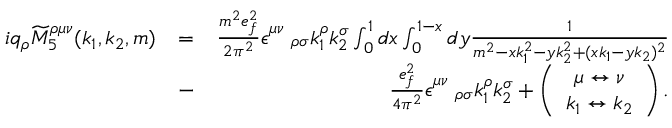<formula> <loc_0><loc_0><loc_500><loc_500>\begin{array} { r l r } { i q _ { \rho } \widetilde { M } _ { 5 } ^ { \rho \mu \nu } ( k _ { 1 } , k _ { 2 } , m ) } & { = } & { \frac { m ^ { 2 } e _ { f } ^ { 2 } } { 2 \pi ^ { 2 } } \epsilon _ { \quad \rho \sigma } ^ { \mu \nu } k _ { 1 } ^ { \rho } k _ { 2 } ^ { \sigma } \int _ { 0 } ^ { 1 } d x \int _ { 0 } ^ { 1 - x } d y \frac { 1 } { m ^ { 2 } - x k _ { 1 } ^ { 2 } - y k _ { 2 } ^ { 2 } + ( x k _ { 1 } - y k _ { 2 } ) ^ { 2 } } } \\ & { - } & { \frac { e _ { f } ^ { 2 } } { 4 \pi ^ { 2 } } \epsilon _ { \quad \rho \sigma } ^ { \mu \nu } k _ { 1 } ^ { \rho } k _ { 2 } ^ { \sigma } + \left ( \begin{array} { c } { \mu \leftrightarrow \nu } \\ { k _ { 1 } \leftrightarrow k _ { 2 } } \end{array} \right ) . } \end{array}</formula> 